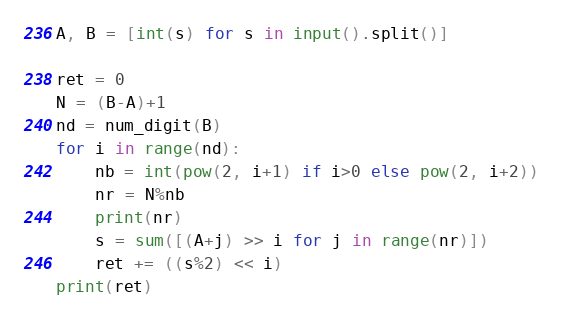Convert code to text. <code><loc_0><loc_0><loc_500><loc_500><_Python_>A, B = [int(s) for s in input().split()]

ret = 0
N = (B-A)+1
nd = num_digit(B)
for i in range(nd):
    nb = int(pow(2, i+1) if i>0 else pow(2, i+2))
    nr = N%nb
    print(nr)
    s = sum([(A+j) >> i for j in range(nr)])
    ret += ((s%2) << i)
print(ret)</code> 